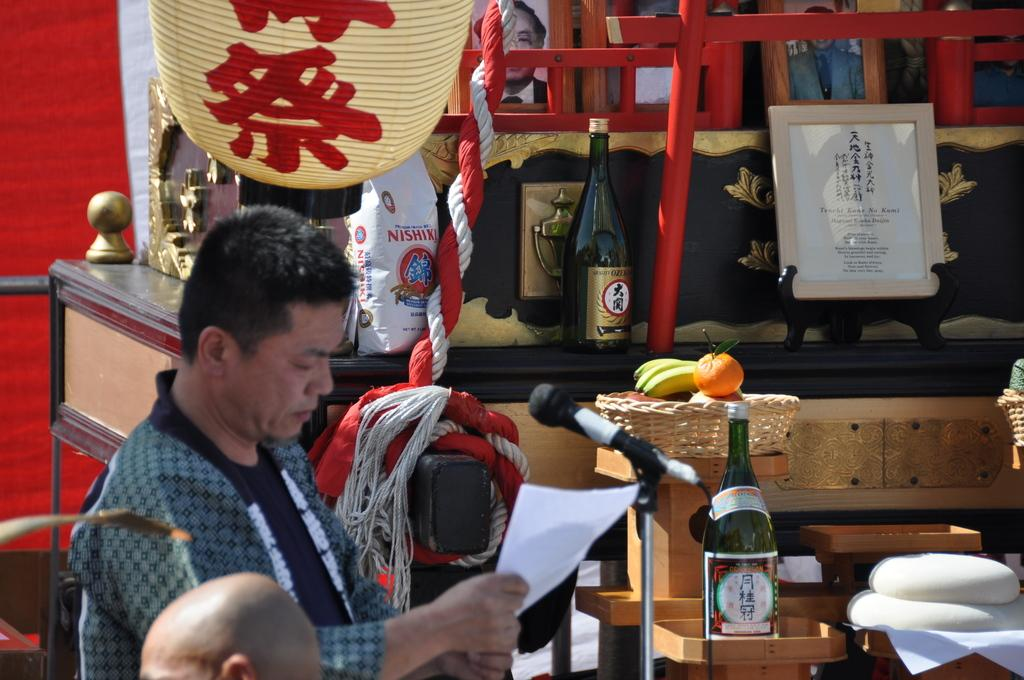Who is the main subject in the image? There is a man in the image. Where is the man positioned in the image? The man is standing on the left side. What object is in front of the man? There is a microphone in front of the man. What other items can be seen in the image? There are wine bottles, photo frames, and a basket full of fruits in the image. What type of attraction is the man operating in the image? There is no attraction present in the image; it is a man standing with a microphone in front of him. What is the man's profit from the system in the image? There is no system or profit mentioned in the image; it only shows a man with a microphone and other items. 